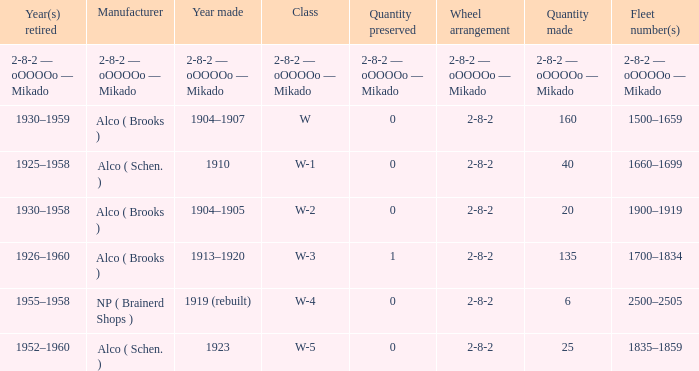What is the year retired of the locomotive which had the quantity made of 25? 1952–1960. 